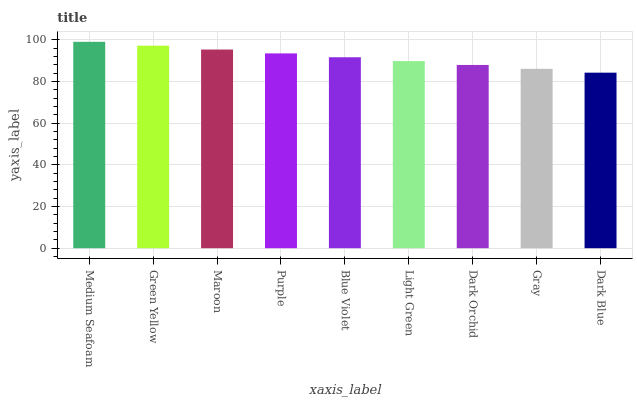Is Dark Blue the minimum?
Answer yes or no. Yes. Is Medium Seafoam the maximum?
Answer yes or no. Yes. Is Green Yellow the minimum?
Answer yes or no. No. Is Green Yellow the maximum?
Answer yes or no. No. Is Medium Seafoam greater than Green Yellow?
Answer yes or no. Yes. Is Green Yellow less than Medium Seafoam?
Answer yes or no. Yes. Is Green Yellow greater than Medium Seafoam?
Answer yes or no. No. Is Medium Seafoam less than Green Yellow?
Answer yes or no. No. Is Blue Violet the high median?
Answer yes or no. Yes. Is Blue Violet the low median?
Answer yes or no. Yes. Is Dark Orchid the high median?
Answer yes or no. No. Is Gray the low median?
Answer yes or no. No. 